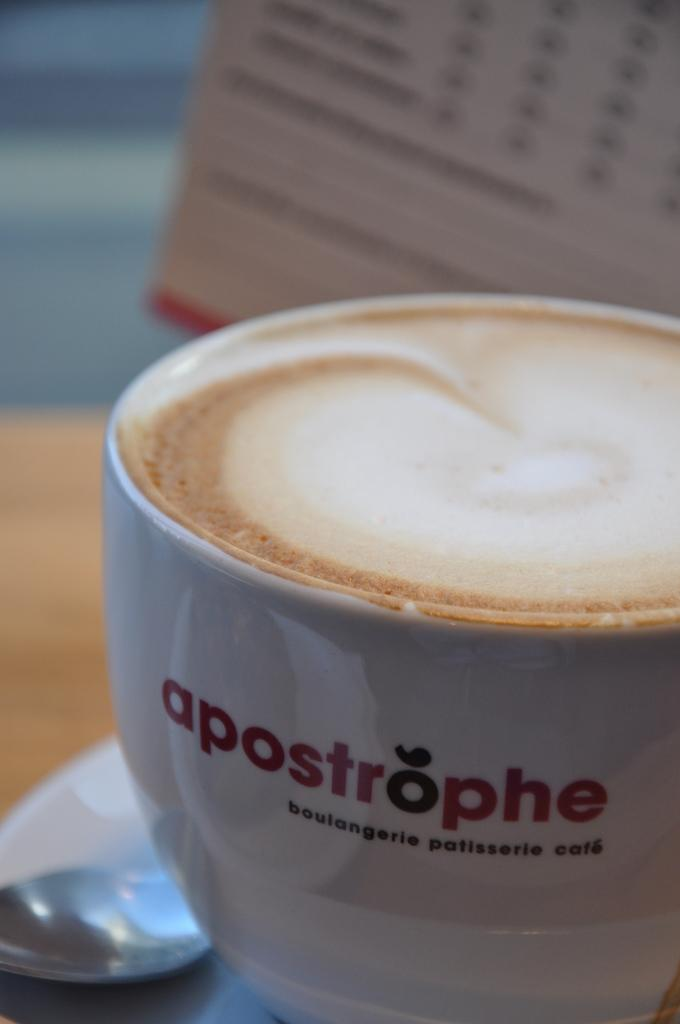What is in the cup that is visible in the image? There is coffee in a cup. What utensil is on the saucer in the image? A spoon is on a saucer. Where is the spoon and saucer located in the image? The spoon and saucer are on a platform. Can you describe the background of the image? There is an object visible in the background, although it is blurred. How many apples are on the platform in the image? There are no apples present on the platform in the image. What note is written on the saucer in the image? There is no note written on the saucer in the image. 